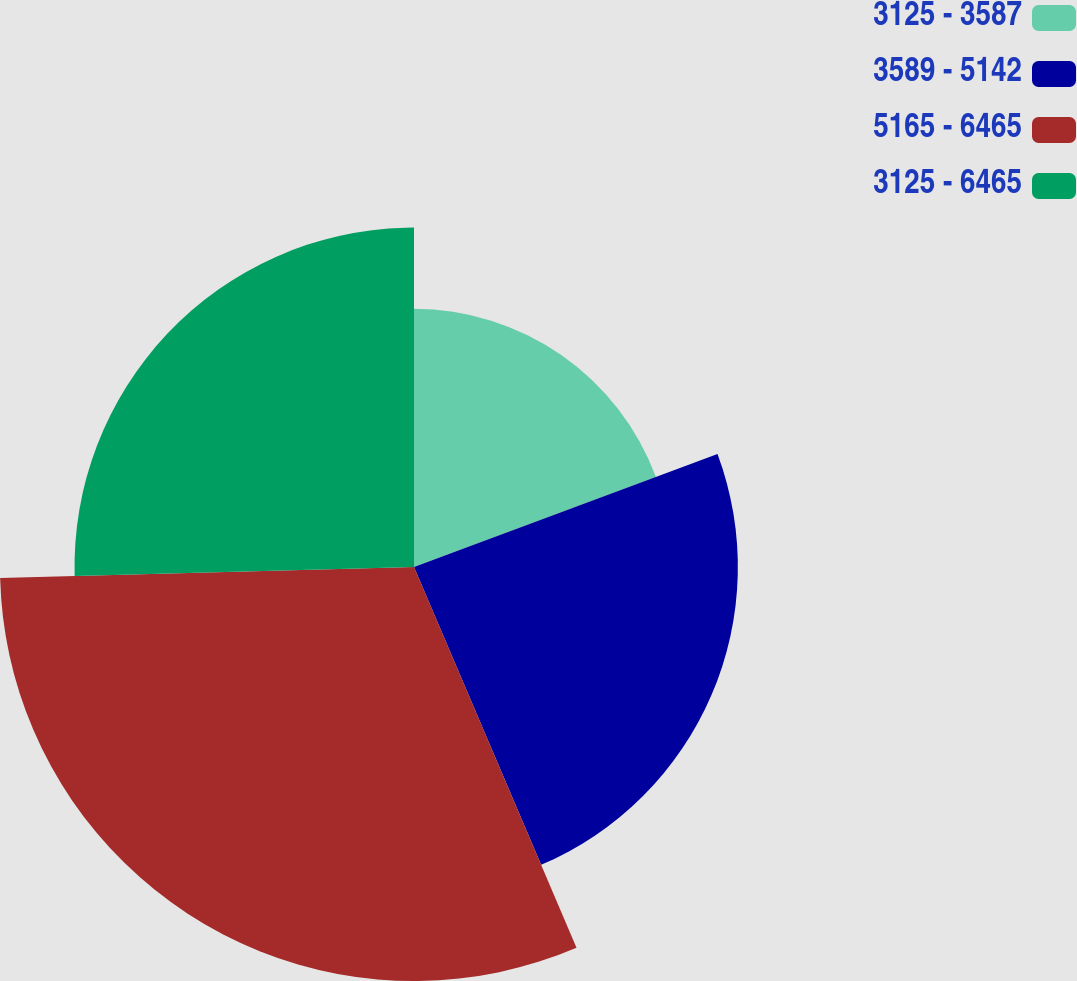Convert chart. <chart><loc_0><loc_0><loc_500><loc_500><pie_chart><fcel>3125 - 3587<fcel>3589 - 5142<fcel>5165 - 6465<fcel>3125 - 6465<nl><fcel>19.33%<fcel>24.25%<fcel>31.0%<fcel>25.42%<nl></chart> 